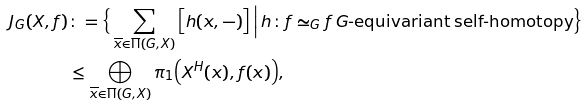Convert formula to latex. <formula><loc_0><loc_0><loc_500><loc_500>J _ { G } ( X , f ) & \colon = \Big \{ \sum _ { \overline { x } \in \Pi ( G , X ) } \Big [ h ( x , - ) \Big ] \, \Big | \, h \colon f \simeq _ { G } f \, G \text {-equivariant self-homotopy} \Big \} \\ & \leq \bigoplus _ { \overline { x } \in \Pi ( G , X ) } \pi _ { 1 } \Big ( X ^ { H } ( x ) , f ( x ) \Big ) ,</formula> 